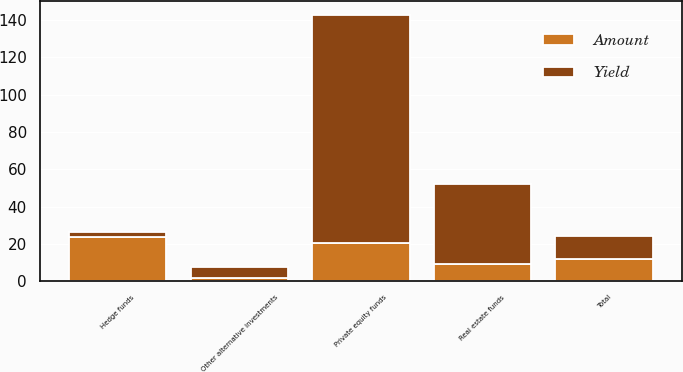Convert chart. <chart><loc_0><loc_0><loc_500><loc_500><stacked_bar_chart><ecel><fcel>Hedge funds<fcel>Real estate funds<fcel>Private equity funds<fcel>Other alternative investments<fcel>Total<nl><fcel>Yield<fcel>3<fcel>43<fcel>122<fcel>6<fcel>12<nl><fcel>Amount<fcel>23.6<fcel>9.1<fcel>20.7<fcel>1.6<fcel>12<nl></chart> 